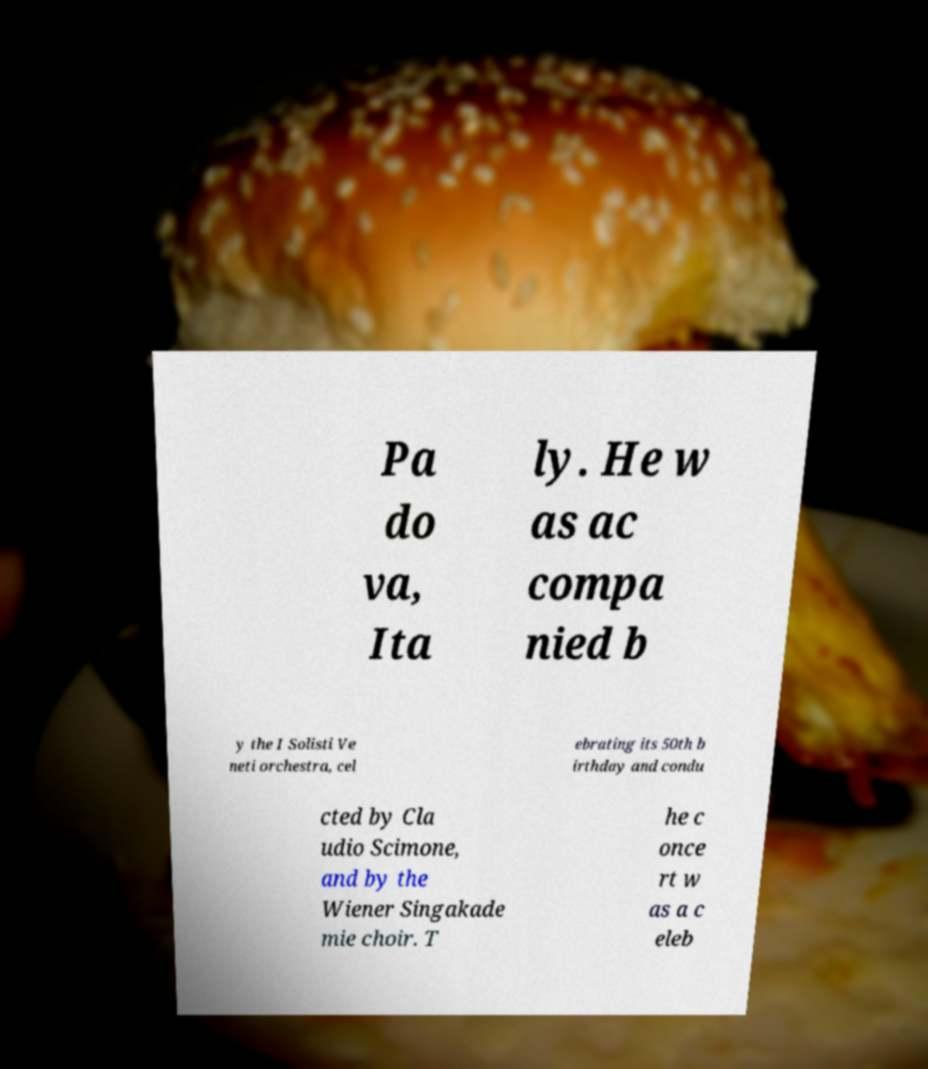For documentation purposes, I need the text within this image transcribed. Could you provide that? Pa do va, Ita ly. He w as ac compa nied b y the I Solisti Ve neti orchestra, cel ebrating its 50th b irthday and condu cted by Cla udio Scimone, and by the Wiener Singakade mie choir. T he c once rt w as a c eleb 